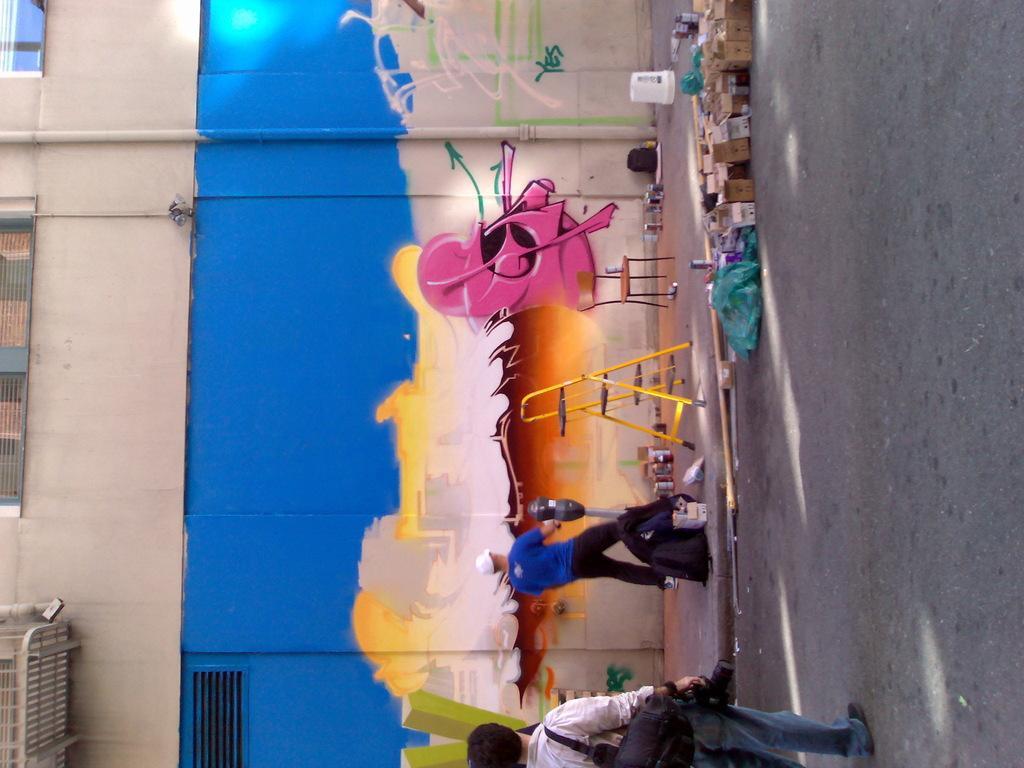How would you summarize this image in a sentence or two? At the bottom of the image we can see one person is standing and he is holding a camera and he is wearing a bag. In the center of the image we can see boxes, cans, bags, one chair, one ladder, one pole type object, one person is standing and holding some object and a few other objects. In the background there is a wall and a few other objects. And we can see some painting on the wall. 